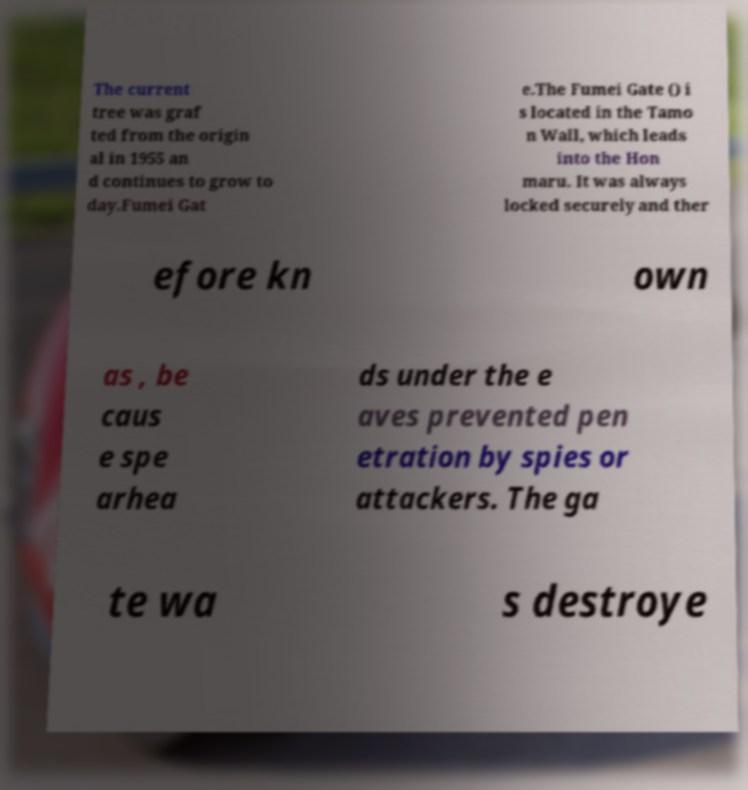What messages or text are displayed in this image? I need them in a readable, typed format. The current tree was graf ted from the origin al in 1955 an d continues to grow to day.Fumei Gat e.The Fumei Gate () i s located in the Tamo n Wall, which leads into the Hon maru. It was always locked securely and ther efore kn own as , be caus e spe arhea ds under the e aves prevented pen etration by spies or attackers. The ga te wa s destroye 